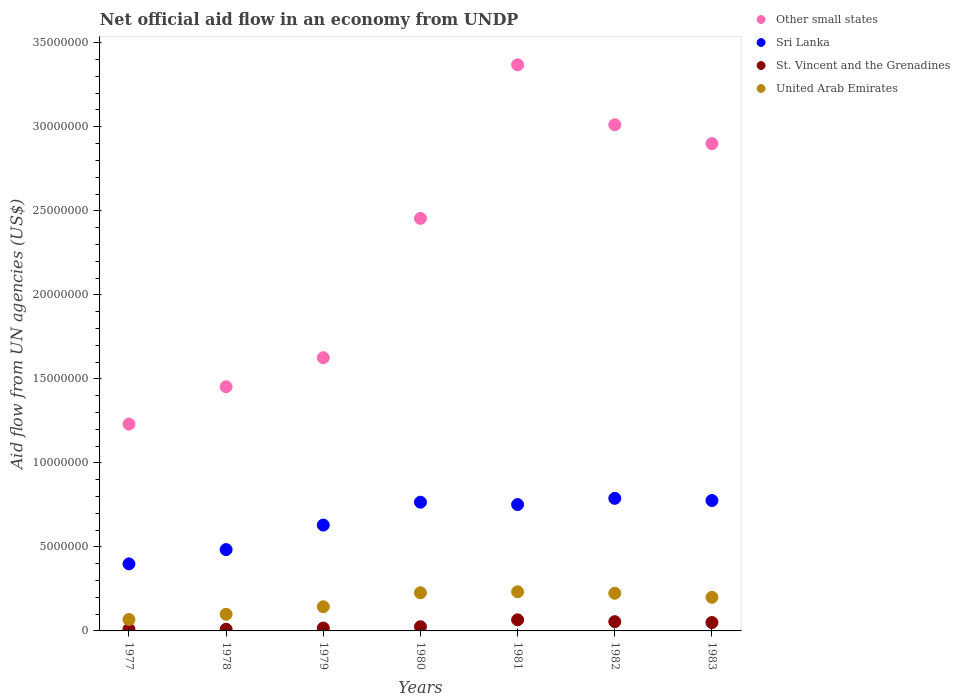What is the net official aid flow in Other small states in 1981?
Give a very brief answer. 3.37e+07. Across all years, what is the maximum net official aid flow in Other small states?
Offer a terse response. 3.37e+07. Across all years, what is the minimum net official aid flow in Other small states?
Provide a short and direct response. 1.23e+07. In which year was the net official aid flow in United Arab Emirates maximum?
Your response must be concise. 1981. What is the total net official aid flow in Other small states in the graph?
Provide a succinct answer. 1.60e+08. What is the difference between the net official aid flow in St. Vincent and the Grenadines in 1978 and that in 1979?
Provide a succinct answer. -7.00e+04. What is the difference between the net official aid flow in St. Vincent and the Grenadines in 1983 and the net official aid flow in United Arab Emirates in 1977?
Your response must be concise. -1.80e+05. What is the average net official aid flow in Sri Lanka per year?
Offer a terse response. 6.57e+06. In the year 1981, what is the difference between the net official aid flow in United Arab Emirates and net official aid flow in Sri Lanka?
Ensure brevity in your answer.  -5.19e+06. In how many years, is the net official aid flow in St. Vincent and the Grenadines greater than 22000000 US$?
Provide a succinct answer. 0. What is the ratio of the net official aid flow in St. Vincent and the Grenadines in 1978 to that in 1982?
Your answer should be very brief. 0.18. Is the difference between the net official aid flow in United Arab Emirates in 1977 and 1983 greater than the difference between the net official aid flow in Sri Lanka in 1977 and 1983?
Your response must be concise. Yes. What is the difference between the highest and the lowest net official aid flow in St. Vincent and the Grenadines?
Make the answer very short. 5.60e+05. In how many years, is the net official aid flow in Sri Lanka greater than the average net official aid flow in Sri Lanka taken over all years?
Your answer should be compact. 4. Is it the case that in every year, the sum of the net official aid flow in St. Vincent and the Grenadines and net official aid flow in Sri Lanka  is greater than the sum of net official aid flow in United Arab Emirates and net official aid flow in Other small states?
Your response must be concise. No. Is the net official aid flow in United Arab Emirates strictly greater than the net official aid flow in Sri Lanka over the years?
Provide a succinct answer. No. What is the difference between two consecutive major ticks on the Y-axis?
Your answer should be compact. 5.00e+06. Does the graph contain any zero values?
Make the answer very short. No. Does the graph contain grids?
Your answer should be compact. No. Where does the legend appear in the graph?
Provide a succinct answer. Top right. How are the legend labels stacked?
Keep it short and to the point. Vertical. What is the title of the graph?
Ensure brevity in your answer.  Net official aid flow in an economy from UNDP. What is the label or title of the Y-axis?
Your answer should be very brief. Aid flow from UN agencies (US$). What is the Aid flow from UN agencies (US$) in Other small states in 1977?
Ensure brevity in your answer.  1.23e+07. What is the Aid flow from UN agencies (US$) in Sri Lanka in 1977?
Provide a short and direct response. 3.99e+06. What is the Aid flow from UN agencies (US$) of United Arab Emirates in 1977?
Provide a succinct answer. 6.80e+05. What is the Aid flow from UN agencies (US$) of Other small states in 1978?
Your answer should be very brief. 1.45e+07. What is the Aid flow from UN agencies (US$) of Sri Lanka in 1978?
Provide a short and direct response. 4.84e+06. What is the Aid flow from UN agencies (US$) in United Arab Emirates in 1978?
Provide a short and direct response. 9.90e+05. What is the Aid flow from UN agencies (US$) in Other small states in 1979?
Your answer should be very brief. 1.63e+07. What is the Aid flow from UN agencies (US$) of Sri Lanka in 1979?
Provide a short and direct response. 6.30e+06. What is the Aid flow from UN agencies (US$) in United Arab Emirates in 1979?
Your answer should be compact. 1.44e+06. What is the Aid flow from UN agencies (US$) in Other small states in 1980?
Offer a terse response. 2.46e+07. What is the Aid flow from UN agencies (US$) in Sri Lanka in 1980?
Your answer should be very brief. 7.66e+06. What is the Aid flow from UN agencies (US$) of United Arab Emirates in 1980?
Provide a succinct answer. 2.27e+06. What is the Aid flow from UN agencies (US$) in Other small states in 1981?
Make the answer very short. 3.37e+07. What is the Aid flow from UN agencies (US$) in Sri Lanka in 1981?
Provide a short and direct response. 7.52e+06. What is the Aid flow from UN agencies (US$) in United Arab Emirates in 1981?
Ensure brevity in your answer.  2.33e+06. What is the Aid flow from UN agencies (US$) in Other small states in 1982?
Give a very brief answer. 3.01e+07. What is the Aid flow from UN agencies (US$) in Sri Lanka in 1982?
Your answer should be very brief. 7.89e+06. What is the Aid flow from UN agencies (US$) in United Arab Emirates in 1982?
Give a very brief answer. 2.24e+06. What is the Aid flow from UN agencies (US$) in Other small states in 1983?
Your answer should be very brief. 2.90e+07. What is the Aid flow from UN agencies (US$) of Sri Lanka in 1983?
Make the answer very short. 7.76e+06. What is the Aid flow from UN agencies (US$) in St. Vincent and the Grenadines in 1983?
Give a very brief answer. 5.00e+05. What is the Aid flow from UN agencies (US$) of United Arab Emirates in 1983?
Provide a succinct answer. 2.00e+06. Across all years, what is the maximum Aid flow from UN agencies (US$) in Other small states?
Make the answer very short. 3.37e+07. Across all years, what is the maximum Aid flow from UN agencies (US$) in Sri Lanka?
Keep it short and to the point. 7.89e+06. Across all years, what is the maximum Aid flow from UN agencies (US$) of St. Vincent and the Grenadines?
Make the answer very short. 6.60e+05. Across all years, what is the maximum Aid flow from UN agencies (US$) in United Arab Emirates?
Ensure brevity in your answer.  2.33e+06. Across all years, what is the minimum Aid flow from UN agencies (US$) in Other small states?
Keep it short and to the point. 1.23e+07. Across all years, what is the minimum Aid flow from UN agencies (US$) of Sri Lanka?
Give a very brief answer. 3.99e+06. Across all years, what is the minimum Aid flow from UN agencies (US$) in United Arab Emirates?
Provide a short and direct response. 6.80e+05. What is the total Aid flow from UN agencies (US$) in Other small states in the graph?
Provide a succinct answer. 1.60e+08. What is the total Aid flow from UN agencies (US$) of Sri Lanka in the graph?
Your response must be concise. 4.60e+07. What is the total Aid flow from UN agencies (US$) in St. Vincent and the Grenadines in the graph?
Give a very brief answer. 2.33e+06. What is the total Aid flow from UN agencies (US$) in United Arab Emirates in the graph?
Your response must be concise. 1.20e+07. What is the difference between the Aid flow from UN agencies (US$) of Other small states in 1977 and that in 1978?
Your answer should be compact. -2.22e+06. What is the difference between the Aid flow from UN agencies (US$) in Sri Lanka in 1977 and that in 1978?
Your answer should be compact. -8.50e+05. What is the difference between the Aid flow from UN agencies (US$) in United Arab Emirates in 1977 and that in 1978?
Keep it short and to the point. -3.10e+05. What is the difference between the Aid flow from UN agencies (US$) of Other small states in 1977 and that in 1979?
Provide a succinct answer. -3.95e+06. What is the difference between the Aid flow from UN agencies (US$) in Sri Lanka in 1977 and that in 1979?
Give a very brief answer. -2.31e+06. What is the difference between the Aid flow from UN agencies (US$) of St. Vincent and the Grenadines in 1977 and that in 1979?
Provide a succinct answer. -7.00e+04. What is the difference between the Aid flow from UN agencies (US$) in United Arab Emirates in 1977 and that in 1979?
Offer a terse response. -7.60e+05. What is the difference between the Aid flow from UN agencies (US$) in Other small states in 1977 and that in 1980?
Keep it short and to the point. -1.22e+07. What is the difference between the Aid flow from UN agencies (US$) in Sri Lanka in 1977 and that in 1980?
Make the answer very short. -3.67e+06. What is the difference between the Aid flow from UN agencies (US$) of St. Vincent and the Grenadines in 1977 and that in 1980?
Your answer should be compact. -1.50e+05. What is the difference between the Aid flow from UN agencies (US$) in United Arab Emirates in 1977 and that in 1980?
Keep it short and to the point. -1.59e+06. What is the difference between the Aid flow from UN agencies (US$) in Other small states in 1977 and that in 1981?
Provide a short and direct response. -2.14e+07. What is the difference between the Aid flow from UN agencies (US$) in Sri Lanka in 1977 and that in 1981?
Offer a very short reply. -3.53e+06. What is the difference between the Aid flow from UN agencies (US$) in St. Vincent and the Grenadines in 1977 and that in 1981?
Make the answer very short. -5.60e+05. What is the difference between the Aid flow from UN agencies (US$) in United Arab Emirates in 1977 and that in 1981?
Provide a short and direct response. -1.65e+06. What is the difference between the Aid flow from UN agencies (US$) of Other small states in 1977 and that in 1982?
Offer a very short reply. -1.78e+07. What is the difference between the Aid flow from UN agencies (US$) in Sri Lanka in 1977 and that in 1982?
Provide a succinct answer. -3.90e+06. What is the difference between the Aid flow from UN agencies (US$) of St. Vincent and the Grenadines in 1977 and that in 1982?
Your answer should be very brief. -4.50e+05. What is the difference between the Aid flow from UN agencies (US$) in United Arab Emirates in 1977 and that in 1982?
Give a very brief answer. -1.56e+06. What is the difference between the Aid flow from UN agencies (US$) in Other small states in 1977 and that in 1983?
Your answer should be compact. -1.67e+07. What is the difference between the Aid flow from UN agencies (US$) of Sri Lanka in 1977 and that in 1983?
Keep it short and to the point. -3.77e+06. What is the difference between the Aid flow from UN agencies (US$) in St. Vincent and the Grenadines in 1977 and that in 1983?
Your answer should be very brief. -4.00e+05. What is the difference between the Aid flow from UN agencies (US$) in United Arab Emirates in 1977 and that in 1983?
Your answer should be compact. -1.32e+06. What is the difference between the Aid flow from UN agencies (US$) in Other small states in 1978 and that in 1979?
Offer a terse response. -1.73e+06. What is the difference between the Aid flow from UN agencies (US$) of Sri Lanka in 1978 and that in 1979?
Offer a very short reply. -1.46e+06. What is the difference between the Aid flow from UN agencies (US$) of St. Vincent and the Grenadines in 1978 and that in 1979?
Provide a short and direct response. -7.00e+04. What is the difference between the Aid flow from UN agencies (US$) of United Arab Emirates in 1978 and that in 1979?
Your answer should be compact. -4.50e+05. What is the difference between the Aid flow from UN agencies (US$) of Other small states in 1978 and that in 1980?
Keep it short and to the point. -1.00e+07. What is the difference between the Aid flow from UN agencies (US$) in Sri Lanka in 1978 and that in 1980?
Ensure brevity in your answer.  -2.82e+06. What is the difference between the Aid flow from UN agencies (US$) of St. Vincent and the Grenadines in 1978 and that in 1980?
Keep it short and to the point. -1.50e+05. What is the difference between the Aid flow from UN agencies (US$) of United Arab Emirates in 1978 and that in 1980?
Provide a succinct answer. -1.28e+06. What is the difference between the Aid flow from UN agencies (US$) of Other small states in 1978 and that in 1981?
Offer a very short reply. -1.92e+07. What is the difference between the Aid flow from UN agencies (US$) of Sri Lanka in 1978 and that in 1981?
Offer a terse response. -2.68e+06. What is the difference between the Aid flow from UN agencies (US$) of St. Vincent and the Grenadines in 1978 and that in 1981?
Keep it short and to the point. -5.60e+05. What is the difference between the Aid flow from UN agencies (US$) in United Arab Emirates in 1978 and that in 1981?
Keep it short and to the point. -1.34e+06. What is the difference between the Aid flow from UN agencies (US$) in Other small states in 1978 and that in 1982?
Your answer should be compact. -1.56e+07. What is the difference between the Aid flow from UN agencies (US$) of Sri Lanka in 1978 and that in 1982?
Ensure brevity in your answer.  -3.05e+06. What is the difference between the Aid flow from UN agencies (US$) of St. Vincent and the Grenadines in 1978 and that in 1982?
Provide a succinct answer. -4.50e+05. What is the difference between the Aid flow from UN agencies (US$) in United Arab Emirates in 1978 and that in 1982?
Your answer should be very brief. -1.25e+06. What is the difference between the Aid flow from UN agencies (US$) in Other small states in 1978 and that in 1983?
Ensure brevity in your answer.  -1.45e+07. What is the difference between the Aid flow from UN agencies (US$) of Sri Lanka in 1978 and that in 1983?
Provide a short and direct response. -2.92e+06. What is the difference between the Aid flow from UN agencies (US$) in St. Vincent and the Grenadines in 1978 and that in 1983?
Provide a short and direct response. -4.00e+05. What is the difference between the Aid flow from UN agencies (US$) in United Arab Emirates in 1978 and that in 1983?
Your answer should be compact. -1.01e+06. What is the difference between the Aid flow from UN agencies (US$) in Other small states in 1979 and that in 1980?
Your answer should be compact. -8.29e+06. What is the difference between the Aid flow from UN agencies (US$) of Sri Lanka in 1979 and that in 1980?
Provide a short and direct response. -1.36e+06. What is the difference between the Aid flow from UN agencies (US$) in United Arab Emirates in 1979 and that in 1980?
Your answer should be very brief. -8.30e+05. What is the difference between the Aid flow from UN agencies (US$) of Other small states in 1979 and that in 1981?
Offer a terse response. -1.74e+07. What is the difference between the Aid flow from UN agencies (US$) in Sri Lanka in 1979 and that in 1981?
Your response must be concise. -1.22e+06. What is the difference between the Aid flow from UN agencies (US$) in St. Vincent and the Grenadines in 1979 and that in 1981?
Your answer should be very brief. -4.90e+05. What is the difference between the Aid flow from UN agencies (US$) of United Arab Emirates in 1979 and that in 1981?
Keep it short and to the point. -8.90e+05. What is the difference between the Aid flow from UN agencies (US$) in Other small states in 1979 and that in 1982?
Provide a short and direct response. -1.39e+07. What is the difference between the Aid flow from UN agencies (US$) of Sri Lanka in 1979 and that in 1982?
Your response must be concise. -1.59e+06. What is the difference between the Aid flow from UN agencies (US$) of St. Vincent and the Grenadines in 1979 and that in 1982?
Make the answer very short. -3.80e+05. What is the difference between the Aid flow from UN agencies (US$) in United Arab Emirates in 1979 and that in 1982?
Give a very brief answer. -8.00e+05. What is the difference between the Aid flow from UN agencies (US$) of Other small states in 1979 and that in 1983?
Ensure brevity in your answer.  -1.27e+07. What is the difference between the Aid flow from UN agencies (US$) of Sri Lanka in 1979 and that in 1983?
Provide a short and direct response. -1.46e+06. What is the difference between the Aid flow from UN agencies (US$) of St. Vincent and the Grenadines in 1979 and that in 1983?
Make the answer very short. -3.30e+05. What is the difference between the Aid flow from UN agencies (US$) of United Arab Emirates in 1979 and that in 1983?
Give a very brief answer. -5.60e+05. What is the difference between the Aid flow from UN agencies (US$) of Other small states in 1980 and that in 1981?
Provide a short and direct response. -9.14e+06. What is the difference between the Aid flow from UN agencies (US$) in Sri Lanka in 1980 and that in 1981?
Provide a succinct answer. 1.40e+05. What is the difference between the Aid flow from UN agencies (US$) of St. Vincent and the Grenadines in 1980 and that in 1981?
Provide a succinct answer. -4.10e+05. What is the difference between the Aid flow from UN agencies (US$) of Other small states in 1980 and that in 1982?
Provide a short and direct response. -5.57e+06. What is the difference between the Aid flow from UN agencies (US$) of St. Vincent and the Grenadines in 1980 and that in 1982?
Your answer should be compact. -3.00e+05. What is the difference between the Aid flow from UN agencies (US$) of Other small states in 1980 and that in 1983?
Your answer should be compact. -4.45e+06. What is the difference between the Aid flow from UN agencies (US$) of St. Vincent and the Grenadines in 1980 and that in 1983?
Provide a short and direct response. -2.50e+05. What is the difference between the Aid flow from UN agencies (US$) in United Arab Emirates in 1980 and that in 1983?
Your response must be concise. 2.70e+05. What is the difference between the Aid flow from UN agencies (US$) in Other small states in 1981 and that in 1982?
Give a very brief answer. 3.57e+06. What is the difference between the Aid flow from UN agencies (US$) in Sri Lanka in 1981 and that in 1982?
Ensure brevity in your answer.  -3.70e+05. What is the difference between the Aid flow from UN agencies (US$) of St. Vincent and the Grenadines in 1981 and that in 1982?
Keep it short and to the point. 1.10e+05. What is the difference between the Aid flow from UN agencies (US$) of Other small states in 1981 and that in 1983?
Give a very brief answer. 4.69e+06. What is the difference between the Aid flow from UN agencies (US$) of St. Vincent and the Grenadines in 1981 and that in 1983?
Ensure brevity in your answer.  1.60e+05. What is the difference between the Aid flow from UN agencies (US$) of Other small states in 1982 and that in 1983?
Your answer should be very brief. 1.12e+06. What is the difference between the Aid flow from UN agencies (US$) in St. Vincent and the Grenadines in 1982 and that in 1983?
Ensure brevity in your answer.  5.00e+04. What is the difference between the Aid flow from UN agencies (US$) in Other small states in 1977 and the Aid flow from UN agencies (US$) in Sri Lanka in 1978?
Offer a terse response. 7.47e+06. What is the difference between the Aid flow from UN agencies (US$) of Other small states in 1977 and the Aid flow from UN agencies (US$) of St. Vincent and the Grenadines in 1978?
Provide a succinct answer. 1.22e+07. What is the difference between the Aid flow from UN agencies (US$) of Other small states in 1977 and the Aid flow from UN agencies (US$) of United Arab Emirates in 1978?
Your answer should be very brief. 1.13e+07. What is the difference between the Aid flow from UN agencies (US$) of Sri Lanka in 1977 and the Aid flow from UN agencies (US$) of St. Vincent and the Grenadines in 1978?
Your answer should be very brief. 3.89e+06. What is the difference between the Aid flow from UN agencies (US$) in Sri Lanka in 1977 and the Aid flow from UN agencies (US$) in United Arab Emirates in 1978?
Provide a short and direct response. 3.00e+06. What is the difference between the Aid flow from UN agencies (US$) of St. Vincent and the Grenadines in 1977 and the Aid flow from UN agencies (US$) of United Arab Emirates in 1978?
Provide a succinct answer. -8.90e+05. What is the difference between the Aid flow from UN agencies (US$) in Other small states in 1977 and the Aid flow from UN agencies (US$) in Sri Lanka in 1979?
Ensure brevity in your answer.  6.01e+06. What is the difference between the Aid flow from UN agencies (US$) in Other small states in 1977 and the Aid flow from UN agencies (US$) in St. Vincent and the Grenadines in 1979?
Your response must be concise. 1.21e+07. What is the difference between the Aid flow from UN agencies (US$) of Other small states in 1977 and the Aid flow from UN agencies (US$) of United Arab Emirates in 1979?
Give a very brief answer. 1.09e+07. What is the difference between the Aid flow from UN agencies (US$) in Sri Lanka in 1977 and the Aid flow from UN agencies (US$) in St. Vincent and the Grenadines in 1979?
Your answer should be compact. 3.82e+06. What is the difference between the Aid flow from UN agencies (US$) in Sri Lanka in 1977 and the Aid flow from UN agencies (US$) in United Arab Emirates in 1979?
Your response must be concise. 2.55e+06. What is the difference between the Aid flow from UN agencies (US$) in St. Vincent and the Grenadines in 1977 and the Aid flow from UN agencies (US$) in United Arab Emirates in 1979?
Provide a succinct answer. -1.34e+06. What is the difference between the Aid flow from UN agencies (US$) of Other small states in 1977 and the Aid flow from UN agencies (US$) of Sri Lanka in 1980?
Offer a terse response. 4.65e+06. What is the difference between the Aid flow from UN agencies (US$) in Other small states in 1977 and the Aid flow from UN agencies (US$) in St. Vincent and the Grenadines in 1980?
Keep it short and to the point. 1.21e+07. What is the difference between the Aid flow from UN agencies (US$) in Other small states in 1977 and the Aid flow from UN agencies (US$) in United Arab Emirates in 1980?
Your answer should be compact. 1.00e+07. What is the difference between the Aid flow from UN agencies (US$) in Sri Lanka in 1977 and the Aid flow from UN agencies (US$) in St. Vincent and the Grenadines in 1980?
Your answer should be compact. 3.74e+06. What is the difference between the Aid flow from UN agencies (US$) of Sri Lanka in 1977 and the Aid flow from UN agencies (US$) of United Arab Emirates in 1980?
Your answer should be compact. 1.72e+06. What is the difference between the Aid flow from UN agencies (US$) of St. Vincent and the Grenadines in 1977 and the Aid flow from UN agencies (US$) of United Arab Emirates in 1980?
Offer a very short reply. -2.17e+06. What is the difference between the Aid flow from UN agencies (US$) of Other small states in 1977 and the Aid flow from UN agencies (US$) of Sri Lanka in 1981?
Your response must be concise. 4.79e+06. What is the difference between the Aid flow from UN agencies (US$) in Other small states in 1977 and the Aid flow from UN agencies (US$) in St. Vincent and the Grenadines in 1981?
Your answer should be compact. 1.16e+07. What is the difference between the Aid flow from UN agencies (US$) of Other small states in 1977 and the Aid flow from UN agencies (US$) of United Arab Emirates in 1981?
Make the answer very short. 9.98e+06. What is the difference between the Aid flow from UN agencies (US$) in Sri Lanka in 1977 and the Aid flow from UN agencies (US$) in St. Vincent and the Grenadines in 1981?
Ensure brevity in your answer.  3.33e+06. What is the difference between the Aid flow from UN agencies (US$) in Sri Lanka in 1977 and the Aid flow from UN agencies (US$) in United Arab Emirates in 1981?
Offer a very short reply. 1.66e+06. What is the difference between the Aid flow from UN agencies (US$) of St. Vincent and the Grenadines in 1977 and the Aid flow from UN agencies (US$) of United Arab Emirates in 1981?
Your answer should be very brief. -2.23e+06. What is the difference between the Aid flow from UN agencies (US$) of Other small states in 1977 and the Aid flow from UN agencies (US$) of Sri Lanka in 1982?
Your answer should be compact. 4.42e+06. What is the difference between the Aid flow from UN agencies (US$) in Other small states in 1977 and the Aid flow from UN agencies (US$) in St. Vincent and the Grenadines in 1982?
Your response must be concise. 1.18e+07. What is the difference between the Aid flow from UN agencies (US$) of Other small states in 1977 and the Aid flow from UN agencies (US$) of United Arab Emirates in 1982?
Your answer should be compact. 1.01e+07. What is the difference between the Aid flow from UN agencies (US$) in Sri Lanka in 1977 and the Aid flow from UN agencies (US$) in St. Vincent and the Grenadines in 1982?
Provide a succinct answer. 3.44e+06. What is the difference between the Aid flow from UN agencies (US$) in Sri Lanka in 1977 and the Aid flow from UN agencies (US$) in United Arab Emirates in 1982?
Keep it short and to the point. 1.75e+06. What is the difference between the Aid flow from UN agencies (US$) of St. Vincent and the Grenadines in 1977 and the Aid flow from UN agencies (US$) of United Arab Emirates in 1982?
Keep it short and to the point. -2.14e+06. What is the difference between the Aid flow from UN agencies (US$) in Other small states in 1977 and the Aid flow from UN agencies (US$) in Sri Lanka in 1983?
Make the answer very short. 4.55e+06. What is the difference between the Aid flow from UN agencies (US$) of Other small states in 1977 and the Aid flow from UN agencies (US$) of St. Vincent and the Grenadines in 1983?
Your response must be concise. 1.18e+07. What is the difference between the Aid flow from UN agencies (US$) of Other small states in 1977 and the Aid flow from UN agencies (US$) of United Arab Emirates in 1983?
Ensure brevity in your answer.  1.03e+07. What is the difference between the Aid flow from UN agencies (US$) of Sri Lanka in 1977 and the Aid flow from UN agencies (US$) of St. Vincent and the Grenadines in 1983?
Your answer should be very brief. 3.49e+06. What is the difference between the Aid flow from UN agencies (US$) of Sri Lanka in 1977 and the Aid flow from UN agencies (US$) of United Arab Emirates in 1983?
Provide a short and direct response. 1.99e+06. What is the difference between the Aid flow from UN agencies (US$) of St. Vincent and the Grenadines in 1977 and the Aid flow from UN agencies (US$) of United Arab Emirates in 1983?
Provide a succinct answer. -1.90e+06. What is the difference between the Aid flow from UN agencies (US$) in Other small states in 1978 and the Aid flow from UN agencies (US$) in Sri Lanka in 1979?
Provide a short and direct response. 8.23e+06. What is the difference between the Aid flow from UN agencies (US$) of Other small states in 1978 and the Aid flow from UN agencies (US$) of St. Vincent and the Grenadines in 1979?
Your answer should be compact. 1.44e+07. What is the difference between the Aid flow from UN agencies (US$) in Other small states in 1978 and the Aid flow from UN agencies (US$) in United Arab Emirates in 1979?
Your response must be concise. 1.31e+07. What is the difference between the Aid flow from UN agencies (US$) of Sri Lanka in 1978 and the Aid flow from UN agencies (US$) of St. Vincent and the Grenadines in 1979?
Offer a very short reply. 4.67e+06. What is the difference between the Aid flow from UN agencies (US$) of Sri Lanka in 1978 and the Aid flow from UN agencies (US$) of United Arab Emirates in 1979?
Keep it short and to the point. 3.40e+06. What is the difference between the Aid flow from UN agencies (US$) of St. Vincent and the Grenadines in 1978 and the Aid flow from UN agencies (US$) of United Arab Emirates in 1979?
Make the answer very short. -1.34e+06. What is the difference between the Aid flow from UN agencies (US$) of Other small states in 1978 and the Aid flow from UN agencies (US$) of Sri Lanka in 1980?
Give a very brief answer. 6.87e+06. What is the difference between the Aid flow from UN agencies (US$) in Other small states in 1978 and the Aid flow from UN agencies (US$) in St. Vincent and the Grenadines in 1980?
Give a very brief answer. 1.43e+07. What is the difference between the Aid flow from UN agencies (US$) in Other small states in 1978 and the Aid flow from UN agencies (US$) in United Arab Emirates in 1980?
Offer a very short reply. 1.23e+07. What is the difference between the Aid flow from UN agencies (US$) of Sri Lanka in 1978 and the Aid flow from UN agencies (US$) of St. Vincent and the Grenadines in 1980?
Your answer should be compact. 4.59e+06. What is the difference between the Aid flow from UN agencies (US$) in Sri Lanka in 1978 and the Aid flow from UN agencies (US$) in United Arab Emirates in 1980?
Your answer should be compact. 2.57e+06. What is the difference between the Aid flow from UN agencies (US$) of St. Vincent and the Grenadines in 1978 and the Aid flow from UN agencies (US$) of United Arab Emirates in 1980?
Your answer should be very brief. -2.17e+06. What is the difference between the Aid flow from UN agencies (US$) of Other small states in 1978 and the Aid flow from UN agencies (US$) of Sri Lanka in 1981?
Your answer should be compact. 7.01e+06. What is the difference between the Aid flow from UN agencies (US$) in Other small states in 1978 and the Aid flow from UN agencies (US$) in St. Vincent and the Grenadines in 1981?
Ensure brevity in your answer.  1.39e+07. What is the difference between the Aid flow from UN agencies (US$) of Other small states in 1978 and the Aid flow from UN agencies (US$) of United Arab Emirates in 1981?
Ensure brevity in your answer.  1.22e+07. What is the difference between the Aid flow from UN agencies (US$) of Sri Lanka in 1978 and the Aid flow from UN agencies (US$) of St. Vincent and the Grenadines in 1981?
Your answer should be very brief. 4.18e+06. What is the difference between the Aid flow from UN agencies (US$) in Sri Lanka in 1978 and the Aid flow from UN agencies (US$) in United Arab Emirates in 1981?
Provide a succinct answer. 2.51e+06. What is the difference between the Aid flow from UN agencies (US$) of St. Vincent and the Grenadines in 1978 and the Aid flow from UN agencies (US$) of United Arab Emirates in 1981?
Keep it short and to the point. -2.23e+06. What is the difference between the Aid flow from UN agencies (US$) in Other small states in 1978 and the Aid flow from UN agencies (US$) in Sri Lanka in 1982?
Give a very brief answer. 6.64e+06. What is the difference between the Aid flow from UN agencies (US$) of Other small states in 1978 and the Aid flow from UN agencies (US$) of St. Vincent and the Grenadines in 1982?
Ensure brevity in your answer.  1.40e+07. What is the difference between the Aid flow from UN agencies (US$) in Other small states in 1978 and the Aid flow from UN agencies (US$) in United Arab Emirates in 1982?
Ensure brevity in your answer.  1.23e+07. What is the difference between the Aid flow from UN agencies (US$) of Sri Lanka in 1978 and the Aid flow from UN agencies (US$) of St. Vincent and the Grenadines in 1982?
Keep it short and to the point. 4.29e+06. What is the difference between the Aid flow from UN agencies (US$) in Sri Lanka in 1978 and the Aid flow from UN agencies (US$) in United Arab Emirates in 1982?
Provide a short and direct response. 2.60e+06. What is the difference between the Aid flow from UN agencies (US$) in St. Vincent and the Grenadines in 1978 and the Aid flow from UN agencies (US$) in United Arab Emirates in 1982?
Keep it short and to the point. -2.14e+06. What is the difference between the Aid flow from UN agencies (US$) in Other small states in 1978 and the Aid flow from UN agencies (US$) in Sri Lanka in 1983?
Provide a short and direct response. 6.77e+06. What is the difference between the Aid flow from UN agencies (US$) of Other small states in 1978 and the Aid flow from UN agencies (US$) of St. Vincent and the Grenadines in 1983?
Ensure brevity in your answer.  1.40e+07. What is the difference between the Aid flow from UN agencies (US$) in Other small states in 1978 and the Aid flow from UN agencies (US$) in United Arab Emirates in 1983?
Your response must be concise. 1.25e+07. What is the difference between the Aid flow from UN agencies (US$) of Sri Lanka in 1978 and the Aid flow from UN agencies (US$) of St. Vincent and the Grenadines in 1983?
Provide a short and direct response. 4.34e+06. What is the difference between the Aid flow from UN agencies (US$) in Sri Lanka in 1978 and the Aid flow from UN agencies (US$) in United Arab Emirates in 1983?
Your answer should be very brief. 2.84e+06. What is the difference between the Aid flow from UN agencies (US$) of St. Vincent and the Grenadines in 1978 and the Aid flow from UN agencies (US$) of United Arab Emirates in 1983?
Provide a short and direct response. -1.90e+06. What is the difference between the Aid flow from UN agencies (US$) of Other small states in 1979 and the Aid flow from UN agencies (US$) of Sri Lanka in 1980?
Provide a succinct answer. 8.60e+06. What is the difference between the Aid flow from UN agencies (US$) of Other small states in 1979 and the Aid flow from UN agencies (US$) of St. Vincent and the Grenadines in 1980?
Provide a succinct answer. 1.60e+07. What is the difference between the Aid flow from UN agencies (US$) of Other small states in 1979 and the Aid flow from UN agencies (US$) of United Arab Emirates in 1980?
Your answer should be very brief. 1.40e+07. What is the difference between the Aid flow from UN agencies (US$) in Sri Lanka in 1979 and the Aid flow from UN agencies (US$) in St. Vincent and the Grenadines in 1980?
Your response must be concise. 6.05e+06. What is the difference between the Aid flow from UN agencies (US$) in Sri Lanka in 1979 and the Aid flow from UN agencies (US$) in United Arab Emirates in 1980?
Give a very brief answer. 4.03e+06. What is the difference between the Aid flow from UN agencies (US$) of St. Vincent and the Grenadines in 1979 and the Aid flow from UN agencies (US$) of United Arab Emirates in 1980?
Provide a short and direct response. -2.10e+06. What is the difference between the Aid flow from UN agencies (US$) of Other small states in 1979 and the Aid flow from UN agencies (US$) of Sri Lanka in 1981?
Make the answer very short. 8.74e+06. What is the difference between the Aid flow from UN agencies (US$) in Other small states in 1979 and the Aid flow from UN agencies (US$) in St. Vincent and the Grenadines in 1981?
Offer a terse response. 1.56e+07. What is the difference between the Aid flow from UN agencies (US$) of Other small states in 1979 and the Aid flow from UN agencies (US$) of United Arab Emirates in 1981?
Ensure brevity in your answer.  1.39e+07. What is the difference between the Aid flow from UN agencies (US$) of Sri Lanka in 1979 and the Aid flow from UN agencies (US$) of St. Vincent and the Grenadines in 1981?
Offer a terse response. 5.64e+06. What is the difference between the Aid flow from UN agencies (US$) of Sri Lanka in 1979 and the Aid flow from UN agencies (US$) of United Arab Emirates in 1981?
Offer a very short reply. 3.97e+06. What is the difference between the Aid flow from UN agencies (US$) in St. Vincent and the Grenadines in 1979 and the Aid flow from UN agencies (US$) in United Arab Emirates in 1981?
Offer a very short reply. -2.16e+06. What is the difference between the Aid flow from UN agencies (US$) of Other small states in 1979 and the Aid flow from UN agencies (US$) of Sri Lanka in 1982?
Offer a terse response. 8.37e+06. What is the difference between the Aid flow from UN agencies (US$) of Other small states in 1979 and the Aid flow from UN agencies (US$) of St. Vincent and the Grenadines in 1982?
Keep it short and to the point. 1.57e+07. What is the difference between the Aid flow from UN agencies (US$) of Other small states in 1979 and the Aid flow from UN agencies (US$) of United Arab Emirates in 1982?
Your answer should be very brief. 1.40e+07. What is the difference between the Aid flow from UN agencies (US$) of Sri Lanka in 1979 and the Aid flow from UN agencies (US$) of St. Vincent and the Grenadines in 1982?
Your answer should be compact. 5.75e+06. What is the difference between the Aid flow from UN agencies (US$) in Sri Lanka in 1979 and the Aid flow from UN agencies (US$) in United Arab Emirates in 1982?
Keep it short and to the point. 4.06e+06. What is the difference between the Aid flow from UN agencies (US$) in St. Vincent and the Grenadines in 1979 and the Aid flow from UN agencies (US$) in United Arab Emirates in 1982?
Your answer should be compact. -2.07e+06. What is the difference between the Aid flow from UN agencies (US$) of Other small states in 1979 and the Aid flow from UN agencies (US$) of Sri Lanka in 1983?
Offer a very short reply. 8.50e+06. What is the difference between the Aid flow from UN agencies (US$) in Other small states in 1979 and the Aid flow from UN agencies (US$) in St. Vincent and the Grenadines in 1983?
Your response must be concise. 1.58e+07. What is the difference between the Aid flow from UN agencies (US$) of Other small states in 1979 and the Aid flow from UN agencies (US$) of United Arab Emirates in 1983?
Keep it short and to the point. 1.43e+07. What is the difference between the Aid flow from UN agencies (US$) in Sri Lanka in 1979 and the Aid flow from UN agencies (US$) in St. Vincent and the Grenadines in 1983?
Provide a short and direct response. 5.80e+06. What is the difference between the Aid flow from UN agencies (US$) in Sri Lanka in 1979 and the Aid flow from UN agencies (US$) in United Arab Emirates in 1983?
Offer a very short reply. 4.30e+06. What is the difference between the Aid flow from UN agencies (US$) of St. Vincent and the Grenadines in 1979 and the Aid flow from UN agencies (US$) of United Arab Emirates in 1983?
Make the answer very short. -1.83e+06. What is the difference between the Aid flow from UN agencies (US$) of Other small states in 1980 and the Aid flow from UN agencies (US$) of Sri Lanka in 1981?
Make the answer very short. 1.70e+07. What is the difference between the Aid flow from UN agencies (US$) of Other small states in 1980 and the Aid flow from UN agencies (US$) of St. Vincent and the Grenadines in 1981?
Offer a terse response. 2.39e+07. What is the difference between the Aid flow from UN agencies (US$) of Other small states in 1980 and the Aid flow from UN agencies (US$) of United Arab Emirates in 1981?
Your answer should be compact. 2.22e+07. What is the difference between the Aid flow from UN agencies (US$) of Sri Lanka in 1980 and the Aid flow from UN agencies (US$) of St. Vincent and the Grenadines in 1981?
Offer a terse response. 7.00e+06. What is the difference between the Aid flow from UN agencies (US$) of Sri Lanka in 1980 and the Aid flow from UN agencies (US$) of United Arab Emirates in 1981?
Provide a succinct answer. 5.33e+06. What is the difference between the Aid flow from UN agencies (US$) of St. Vincent and the Grenadines in 1980 and the Aid flow from UN agencies (US$) of United Arab Emirates in 1981?
Provide a short and direct response. -2.08e+06. What is the difference between the Aid flow from UN agencies (US$) of Other small states in 1980 and the Aid flow from UN agencies (US$) of Sri Lanka in 1982?
Provide a succinct answer. 1.67e+07. What is the difference between the Aid flow from UN agencies (US$) in Other small states in 1980 and the Aid flow from UN agencies (US$) in St. Vincent and the Grenadines in 1982?
Keep it short and to the point. 2.40e+07. What is the difference between the Aid flow from UN agencies (US$) of Other small states in 1980 and the Aid flow from UN agencies (US$) of United Arab Emirates in 1982?
Offer a terse response. 2.23e+07. What is the difference between the Aid flow from UN agencies (US$) of Sri Lanka in 1980 and the Aid flow from UN agencies (US$) of St. Vincent and the Grenadines in 1982?
Offer a very short reply. 7.11e+06. What is the difference between the Aid flow from UN agencies (US$) of Sri Lanka in 1980 and the Aid flow from UN agencies (US$) of United Arab Emirates in 1982?
Your answer should be very brief. 5.42e+06. What is the difference between the Aid flow from UN agencies (US$) in St. Vincent and the Grenadines in 1980 and the Aid flow from UN agencies (US$) in United Arab Emirates in 1982?
Provide a succinct answer. -1.99e+06. What is the difference between the Aid flow from UN agencies (US$) of Other small states in 1980 and the Aid flow from UN agencies (US$) of Sri Lanka in 1983?
Your response must be concise. 1.68e+07. What is the difference between the Aid flow from UN agencies (US$) in Other small states in 1980 and the Aid flow from UN agencies (US$) in St. Vincent and the Grenadines in 1983?
Ensure brevity in your answer.  2.40e+07. What is the difference between the Aid flow from UN agencies (US$) of Other small states in 1980 and the Aid flow from UN agencies (US$) of United Arab Emirates in 1983?
Your answer should be compact. 2.26e+07. What is the difference between the Aid flow from UN agencies (US$) in Sri Lanka in 1980 and the Aid flow from UN agencies (US$) in St. Vincent and the Grenadines in 1983?
Make the answer very short. 7.16e+06. What is the difference between the Aid flow from UN agencies (US$) in Sri Lanka in 1980 and the Aid flow from UN agencies (US$) in United Arab Emirates in 1983?
Your response must be concise. 5.66e+06. What is the difference between the Aid flow from UN agencies (US$) in St. Vincent and the Grenadines in 1980 and the Aid flow from UN agencies (US$) in United Arab Emirates in 1983?
Your answer should be compact. -1.75e+06. What is the difference between the Aid flow from UN agencies (US$) of Other small states in 1981 and the Aid flow from UN agencies (US$) of Sri Lanka in 1982?
Offer a very short reply. 2.58e+07. What is the difference between the Aid flow from UN agencies (US$) in Other small states in 1981 and the Aid flow from UN agencies (US$) in St. Vincent and the Grenadines in 1982?
Keep it short and to the point. 3.31e+07. What is the difference between the Aid flow from UN agencies (US$) of Other small states in 1981 and the Aid flow from UN agencies (US$) of United Arab Emirates in 1982?
Give a very brief answer. 3.14e+07. What is the difference between the Aid flow from UN agencies (US$) of Sri Lanka in 1981 and the Aid flow from UN agencies (US$) of St. Vincent and the Grenadines in 1982?
Offer a terse response. 6.97e+06. What is the difference between the Aid flow from UN agencies (US$) of Sri Lanka in 1981 and the Aid flow from UN agencies (US$) of United Arab Emirates in 1982?
Provide a succinct answer. 5.28e+06. What is the difference between the Aid flow from UN agencies (US$) of St. Vincent and the Grenadines in 1981 and the Aid flow from UN agencies (US$) of United Arab Emirates in 1982?
Provide a short and direct response. -1.58e+06. What is the difference between the Aid flow from UN agencies (US$) in Other small states in 1981 and the Aid flow from UN agencies (US$) in Sri Lanka in 1983?
Provide a short and direct response. 2.59e+07. What is the difference between the Aid flow from UN agencies (US$) in Other small states in 1981 and the Aid flow from UN agencies (US$) in St. Vincent and the Grenadines in 1983?
Keep it short and to the point. 3.32e+07. What is the difference between the Aid flow from UN agencies (US$) in Other small states in 1981 and the Aid flow from UN agencies (US$) in United Arab Emirates in 1983?
Keep it short and to the point. 3.17e+07. What is the difference between the Aid flow from UN agencies (US$) in Sri Lanka in 1981 and the Aid flow from UN agencies (US$) in St. Vincent and the Grenadines in 1983?
Give a very brief answer. 7.02e+06. What is the difference between the Aid flow from UN agencies (US$) of Sri Lanka in 1981 and the Aid flow from UN agencies (US$) of United Arab Emirates in 1983?
Your answer should be compact. 5.52e+06. What is the difference between the Aid flow from UN agencies (US$) of St. Vincent and the Grenadines in 1981 and the Aid flow from UN agencies (US$) of United Arab Emirates in 1983?
Ensure brevity in your answer.  -1.34e+06. What is the difference between the Aid flow from UN agencies (US$) of Other small states in 1982 and the Aid flow from UN agencies (US$) of Sri Lanka in 1983?
Provide a short and direct response. 2.24e+07. What is the difference between the Aid flow from UN agencies (US$) of Other small states in 1982 and the Aid flow from UN agencies (US$) of St. Vincent and the Grenadines in 1983?
Offer a terse response. 2.96e+07. What is the difference between the Aid flow from UN agencies (US$) in Other small states in 1982 and the Aid flow from UN agencies (US$) in United Arab Emirates in 1983?
Offer a very short reply. 2.81e+07. What is the difference between the Aid flow from UN agencies (US$) in Sri Lanka in 1982 and the Aid flow from UN agencies (US$) in St. Vincent and the Grenadines in 1983?
Provide a short and direct response. 7.39e+06. What is the difference between the Aid flow from UN agencies (US$) in Sri Lanka in 1982 and the Aid flow from UN agencies (US$) in United Arab Emirates in 1983?
Your answer should be very brief. 5.89e+06. What is the difference between the Aid flow from UN agencies (US$) of St. Vincent and the Grenadines in 1982 and the Aid flow from UN agencies (US$) of United Arab Emirates in 1983?
Provide a short and direct response. -1.45e+06. What is the average Aid flow from UN agencies (US$) in Other small states per year?
Your response must be concise. 2.29e+07. What is the average Aid flow from UN agencies (US$) in Sri Lanka per year?
Make the answer very short. 6.57e+06. What is the average Aid flow from UN agencies (US$) in St. Vincent and the Grenadines per year?
Give a very brief answer. 3.33e+05. What is the average Aid flow from UN agencies (US$) of United Arab Emirates per year?
Give a very brief answer. 1.71e+06. In the year 1977, what is the difference between the Aid flow from UN agencies (US$) in Other small states and Aid flow from UN agencies (US$) in Sri Lanka?
Your response must be concise. 8.32e+06. In the year 1977, what is the difference between the Aid flow from UN agencies (US$) in Other small states and Aid flow from UN agencies (US$) in St. Vincent and the Grenadines?
Give a very brief answer. 1.22e+07. In the year 1977, what is the difference between the Aid flow from UN agencies (US$) of Other small states and Aid flow from UN agencies (US$) of United Arab Emirates?
Provide a short and direct response. 1.16e+07. In the year 1977, what is the difference between the Aid flow from UN agencies (US$) in Sri Lanka and Aid flow from UN agencies (US$) in St. Vincent and the Grenadines?
Your answer should be compact. 3.89e+06. In the year 1977, what is the difference between the Aid flow from UN agencies (US$) of Sri Lanka and Aid flow from UN agencies (US$) of United Arab Emirates?
Keep it short and to the point. 3.31e+06. In the year 1977, what is the difference between the Aid flow from UN agencies (US$) in St. Vincent and the Grenadines and Aid flow from UN agencies (US$) in United Arab Emirates?
Make the answer very short. -5.80e+05. In the year 1978, what is the difference between the Aid flow from UN agencies (US$) in Other small states and Aid flow from UN agencies (US$) in Sri Lanka?
Give a very brief answer. 9.69e+06. In the year 1978, what is the difference between the Aid flow from UN agencies (US$) of Other small states and Aid flow from UN agencies (US$) of St. Vincent and the Grenadines?
Give a very brief answer. 1.44e+07. In the year 1978, what is the difference between the Aid flow from UN agencies (US$) of Other small states and Aid flow from UN agencies (US$) of United Arab Emirates?
Your response must be concise. 1.35e+07. In the year 1978, what is the difference between the Aid flow from UN agencies (US$) of Sri Lanka and Aid flow from UN agencies (US$) of St. Vincent and the Grenadines?
Offer a terse response. 4.74e+06. In the year 1978, what is the difference between the Aid flow from UN agencies (US$) of Sri Lanka and Aid flow from UN agencies (US$) of United Arab Emirates?
Provide a succinct answer. 3.85e+06. In the year 1978, what is the difference between the Aid flow from UN agencies (US$) of St. Vincent and the Grenadines and Aid flow from UN agencies (US$) of United Arab Emirates?
Make the answer very short. -8.90e+05. In the year 1979, what is the difference between the Aid flow from UN agencies (US$) of Other small states and Aid flow from UN agencies (US$) of Sri Lanka?
Provide a short and direct response. 9.96e+06. In the year 1979, what is the difference between the Aid flow from UN agencies (US$) in Other small states and Aid flow from UN agencies (US$) in St. Vincent and the Grenadines?
Your response must be concise. 1.61e+07. In the year 1979, what is the difference between the Aid flow from UN agencies (US$) in Other small states and Aid flow from UN agencies (US$) in United Arab Emirates?
Your answer should be very brief. 1.48e+07. In the year 1979, what is the difference between the Aid flow from UN agencies (US$) of Sri Lanka and Aid flow from UN agencies (US$) of St. Vincent and the Grenadines?
Offer a very short reply. 6.13e+06. In the year 1979, what is the difference between the Aid flow from UN agencies (US$) of Sri Lanka and Aid flow from UN agencies (US$) of United Arab Emirates?
Provide a short and direct response. 4.86e+06. In the year 1979, what is the difference between the Aid flow from UN agencies (US$) in St. Vincent and the Grenadines and Aid flow from UN agencies (US$) in United Arab Emirates?
Keep it short and to the point. -1.27e+06. In the year 1980, what is the difference between the Aid flow from UN agencies (US$) of Other small states and Aid flow from UN agencies (US$) of Sri Lanka?
Your answer should be very brief. 1.69e+07. In the year 1980, what is the difference between the Aid flow from UN agencies (US$) in Other small states and Aid flow from UN agencies (US$) in St. Vincent and the Grenadines?
Ensure brevity in your answer.  2.43e+07. In the year 1980, what is the difference between the Aid flow from UN agencies (US$) in Other small states and Aid flow from UN agencies (US$) in United Arab Emirates?
Provide a succinct answer. 2.23e+07. In the year 1980, what is the difference between the Aid flow from UN agencies (US$) in Sri Lanka and Aid flow from UN agencies (US$) in St. Vincent and the Grenadines?
Make the answer very short. 7.41e+06. In the year 1980, what is the difference between the Aid flow from UN agencies (US$) of Sri Lanka and Aid flow from UN agencies (US$) of United Arab Emirates?
Your answer should be very brief. 5.39e+06. In the year 1980, what is the difference between the Aid flow from UN agencies (US$) in St. Vincent and the Grenadines and Aid flow from UN agencies (US$) in United Arab Emirates?
Keep it short and to the point. -2.02e+06. In the year 1981, what is the difference between the Aid flow from UN agencies (US$) of Other small states and Aid flow from UN agencies (US$) of Sri Lanka?
Ensure brevity in your answer.  2.62e+07. In the year 1981, what is the difference between the Aid flow from UN agencies (US$) of Other small states and Aid flow from UN agencies (US$) of St. Vincent and the Grenadines?
Offer a very short reply. 3.30e+07. In the year 1981, what is the difference between the Aid flow from UN agencies (US$) of Other small states and Aid flow from UN agencies (US$) of United Arab Emirates?
Your answer should be very brief. 3.14e+07. In the year 1981, what is the difference between the Aid flow from UN agencies (US$) in Sri Lanka and Aid flow from UN agencies (US$) in St. Vincent and the Grenadines?
Provide a succinct answer. 6.86e+06. In the year 1981, what is the difference between the Aid flow from UN agencies (US$) in Sri Lanka and Aid flow from UN agencies (US$) in United Arab Emirates?
Ensure brevity in your answer.  5.19e+06. In the year 1981, what is the difference between the Aid flow from UN agencies (US$) in St. Vincent and the Grenadines and Aid flow from UN agencies (US$) in United Arab Emirates?
Ensure brevity in your answer.  -1.67e+06. In the year 1982, what is the difference between the Aid flow from UN agencies (US$) in Other small states and Aid flow from UN agencies (US$) in Sri Lanka?
Your answer should be compact. 2.22e+07. In the year 1982, what is the difference between the Aid flow from UN agencies (US$) of Other small states and Aid flow from UN agencies (US$) of St. Vincent and the Grenadines?
Ensure brevity in your answer.  2.96e+07. In the year 1982, what is the difference between the Aid flow from UN agencies (US$) in Other small states and Aid flow from UN agencies (US$) in United Arab Emirates?
Ensure brevity in your answer.  2.79e+07. In the year 1982, what is the difference between the Aid flow from UN agencies (US$) in Sri Lanka and Aid flow from UN agencies (US$) in St. Vincent and the Grenadines?
Provide a succinct answer. 7.34e+06. In the year 1982, what is the difference between the Aid flow from UN agencies (US$) in Sri Lanka and Aid flow from UN agencies (US$) in United Arab Emirates?
Keep it short and to the point. 5.65e+06. In the year 1982, what is the difference between the Aid flow from UN agencies (US$) in St. Vincent and the Grenadines and Aid flow from UN agencies (US$) in United Arab Emirates?
Offer a terse response. -1.69e+06. In the year 1983, what is the difference between the Aid flow from UN agencies (US$) in Other small states and Aid flow from UN agencies (US$) in Sri Lanka?
Ensure brevity in your answer.  2.12e+07. In the year 1983, what is the difference between the Aid flow from UN agencies (US$) in Other small states and Aid flow from UN agencies (US$) in St. Vincent and the Grenadines?
Give a very brief answer. 2.85e+07. In the year 1983, what is the difference between the Aid flow from UN agencies (US$) of Other small states and Aid flow from UN agencies (US$) of United Arab Emirates?
Provide a short and direct response. 2.70e+07. In the year 1983, what is the difference between the Aid flow from UN agencies (US$) of Sri Lanka and Aid flow from UN agencies (US$) of St. Vincent and the Grenadines?
Give a very brief answer. 7.26e+06. In the year 1983, what is the difference between the Aid flow from UN agencies (US$) of Sri Lanka and Aid flow from UN agencies (US$) of United Arab Emirates?
Offer a terse response. 5.76e+06. In the year 1983, what is the difference between the Aid flow from UN agencies (US$) in St. Vincent and the Grenadines and Aid flow from UN agencies (US$) in United Arab Emirates?
Make the answer very short. -1.50e+06. What is the ratio of the Aid flow from UN agencies (US$) in Other small states in 1977 to that in 1978?
Your answer should be very brief. 0.85. What is the ratio of the Aid flow from UN agencies (US$) in Sri Lanka in 1977 to that in 1978?
Give a very brief answer. 0.82. What is the ratio of the Aid flow from UN agencies (US$) of St. Vincent and the Grenadines in 1977 to that in 1978?
Your answer should be very brief. 1. What is the ratio of the Aid flow from UN agencies (US$) in United Arab Emirates in 1977 to that in 1978?
Provide a succinct answer. 0.69. What is the ratio of the Aid flow from UN agencies (US$) in Other small states in 1977 to that in 1979?
Your answer should be compact. 0.76. What is the ratio of the Aid flow from UN agencies (US$) of Sri Lanka in 1977 to that in 1979?
Your response must be concise. 0.63. What is the ratio of the Aid flow from UN agencies (US$) of St. Vincent and the Grenadines in 1977 to that in 1979?
Give a very brief answer. 0.59. What is the ratio of the Aid flow from UN agencies (US$) of United Arab Emirates in 1977 to that in 1979?
Make the answer very short. 0.47. What is the ratio of the Aid flow from UN agencies (US$) of Other small states in 1977 to that in 1980?
Offer a very short reply. 0.5. What is the ratio of the Aid flow from UN agencies (US$) of Sri Lanka in 1977 to that in 1980?
Offer a very short reply. 0.52. What is the ratio of the Aid flow from UN agencies (US$) of St. Vincent and the Grenadines in 1977 to that in 1980?
Offer a very short reply. 0.4. What is the ratio of the Aid flow from UN agencies (US$) of United Arab Emirates in 1977 to that in 1980?
Provide a short and direct response. 0.3. What is the ratio of the Aid flow from UN agencies (US$) in Other small states in 1977 to that in 1981?
Ensure brevity in your answer.  0.37. What is the ratio of the Aid flow from UN agencies (US$) of Sri Lanka in 1977 to that in 1981?
Your response must be concise. 0.53. What is the ratio of the Aid flow from UN agencies (US$) of St. Vincent and the Grenadines in 1977 to that in 1981?
Your response must be concise. 0.15. What is the ratio of the Aid flow from UN agencies (US$) in United Arab Emirates in 1977 to that in 1981?
Ensure brevity in your answer.  0.29. What is the ratio of the Aid flow from UN agencies (US$) in Other small states in 1977 to that in 1982?
Your answer should be compact. 0.41. What is the ratio of the Aid flow from UN agencies (US$) in Sri Lanka in 1977 to that in 1982?
Ensure brevity in your answer.  0.51. What is the ratio of the Aid flow from UN agencies (US$) of St. Vincent and the Grenadines in 1977 to that in 1982?
Provide a short and direct response. 0.18. What is the ratio of the Aid flow from UN agencies (US$) of United Arab Emirates in 1977 to that in 1982?
Your answer should be compact. 0.3. What is the ratio of the Aid flow from UN agencies (US$) in Other small states in 1977 to that in 1983?
Your response must be concise. 0.42. What is the ratio of the Aid flow from UN agencies (US$) in Sri Lanka in 1977 to that in 1983?
Ensure brevity in your answer.  0.51. What is the ratio of the Aid flow from UN agencies (US$) in St. Vincent and the Grenadines in 1977 to that in 1983?
Offer a very short reply. 0.2. What is the ratio of the Aid flow from UN agencies (US$) of United Arab Emirates in 1977 to that in 1983?
Provide a succinct answer. 0.34. What is the ratio of the Aid flow from UN agencies (US$) in Other small states in 1978 to that in 1979?
Give a very brief answer. 0.89. What is the ratio of the Aid flow from UN agencies (US$) of Sri Lanka in 1978 to that in 1979?
Your answer should be compact. 0.77. What is the ratio of the Aid flow from UN agencies (US$) in St. Vincent and the Grenadines in 1978 to that in 1979?
Make the answer very short. 0.59. What is the ratio of the Aid flow from UN agencies (US$) of United Arab Emirates in 1978 to that in 1979?
Your response must be concise. 0.69. What is the ratio of the Aid flow from UN agencies (US$) in Other small states in 1978 to that in 1980?
Offer a very short reply. 0.59. What is the ratio of the Aid flow from UN agencies (US$) in Sri Lanka in 1978 to that in 1980?
Your response must be concise. 0.63. What is the ratio of the Aid flow from UN agencies (US$) of United Arab Emirates in 1978 to that in 1980?
Make the answer very short. 0.44. What is the ratio of the Aid flow from UN agencies (US$) in Other small states in 1978 to that in 1981?
Keep it short and to the point. 0.43. What is the ratio of the Aid flow from UN agencies (US$) of Sri Lanka in 1978 to that in 1981?
Ensure brevity in your answer.  0.64. What is the ratio of the Aid flow from UN agencies (US$) in St. Vincent and the Grenadines in 1978 to that in 1981?
Provide a succinct answer. 0.15. What is the ratio of the Aid flow from UN agencies (US$) in United Arab Emirates in 1978 to that in 1981?
Offer a terse response. 0.42. What is the ratio of the Aid flow from UN agencies (US$) in Other small states in 1978 to that in 1982?
Offer a very short reply. 0.48. What is the ratio of the Aid flow from UN agencies (US$) of Sri Lanka in 1978 to that in 1982?
Your response must be concise. 0.61. What is the ratio of the Aid flow from UN agencies (US$) of St. Vincent and the Grenadines in 1978 to that in 1982?
Provide a succinct answer. 0.18. What is the ratio of the Aid flow from UN agencies (US$) in United Arab Emirates in 1978 to that in 1982?
Keep it short and to the point. 0.44. What is the ratio of the Aid flow from UN agencies (US$) in Other small states in 1978 to that in 1983?
Keep it short and to the point. 0.5. What is the ratio of the Aid flow from UN agencies (US$) of Sri Lanka in 1978 to that in 1983?
Provide a succinct answer. 0.62. What is the ratio of the Aid flow from UN agencies (US$) of United Arab Emirates in 1978 to that in 1983?
Your answer should be compact. 0.49. What is the ratio of the Aid flow from UN agencies (US$) in Other small states in 1979 to that in 1980?
Keep it short and to the point. 0.66. What is the ratio of the Aid flow from UN agencies (US$) of Sri Lanka in 1979 to that in 1980?
Give a very brief answer. 0.82. What is the ratio of the Aid flow from UN agencies (US$) in St. Vincent and the Grenadines in 1979 to that in 1980?
Make the answer very short. 0.68. What is the ratio of the Aid flow from UN agencies (US$) of United Arab Emirates in 1979 to that in 1980?
Give a very brief answer. 0.63. What is the ratio of the Aid flow from UN agencies (US$) of Other small states in 1979 to that in 1981?
Provide a succinct answer. 0.48. What is the ratio of the Aid flow from UN agencies (US$) of Sri Lanka in 1979 to that in 1981?
Make the answer very short. 0.84. What is the ratio of the Aid flow from UN agencies (US$) in St. Vincent and the Grenadines in 1979 to that in 1981?
Give a very brief answer. 0.26. What is the ratio of the Aid flow from UN agencies (US$) of United Arab Emirates in 1979 to that in 1981?
Make the answer very short. 0.62. What is the ratio of the Aid flow from UN agencies (US$) in Other small states in 1979 to that in 1982?
Keep it short and to the point. 0.54. What is the ratio of the Aid flow from UN agencies (US$) in Sri Lanka in 1979 to that in 1982?
Offer a terse response. 0.8. What is the ratio of the Aid flow from UN agencies (US$) in St. Vincent and the Grenadines in 1979 to that in 1982?
Make the answer very short. 0.31. What is the ratio of the Aid flow from UN agencies (US$) in United Arab Emirates in 1979 to that in 1982?
Offer a very short reply. 0.64. What is the ratio of the Aid flow from UN agencies (US$) of Other small states in 1979 to that in 1983?
Provide a succinct answer. 0.56. What is the ratio of the Aid flow from UN agencies (US$) of Sri Lanka in 1979 to that in 1983?
Give a very brief answer. 0.81. What is the ratio of the Aid flow from UN agencies (US$) in St. Vincent and the Grenadines in 1979 to that in 1983?
Provide a short and direct response. 0.34. What is the ratio of the Aid flow from UN agencies (US$) of United Arab Emirates in 1979 to that in 1983?
Give a very brief answer. 0.72. What is the ratio of the Aid flow from UN agencies (US$) of Other small states in 1980 to that in 1981?
Your response must be concise. 0.73. What is the ratio of the Aid flow from UN agencies (US$) in Sri Lanka in 1980 to that in 1981?
Provide a succinct answer. 1.02. What is the ratio of the Aid flow from UN agencies (US$) of St. Vincent and the Grenadines in 1980 to that in 1981?
Your answer should be very brief. 0.38. What is the ratio of the Aid flow from UN agencies (US$) in United Arab Emirates in 1980 to that in 1981?
Your answer should be compact. 0.97. What is the ratio of the Aid flow from UN agencies (US$) in Other small states in 1980 to that in 1982?
Your response must be concise. 0.82. What is the ratio of the Aid flow from UN agencies (US$) in Sri Lanka in 1980 to that in 1982?
Your answer should be compact. 0.97. What is the ratio of the Aid flow from UN agencies (US$) of St. Vincent and the Grenadines in 1980 to that in 1982?
Your answer should be very brief. 0.45. What is the ratio of the Aid flow from UN agencies (US$) of United Arab Emirates in 1980 to that in 1982?
Your response must be concise. 1.01. What is the ratio of the Aid flow from UN agencies (US$) of Other small states in 1980 to that in 1983?
Your answer should be compact. 0.85. What is the ratio of the Aid flow from UN agencies (US$) in Sri Lanka in 1980 to that in 1983?
Offer a terse response. 0.99. What is the ratio of the Aid flow from UN agencies (US$) of United Arab Emirates in 1980 to that in 1983?
Provide a short and direct response. 1.14. What is the ratio of the Aid flow from UN agencies (US$) of Other small states in 1981 to that in 1982?
Offer a very short reply. 1.12. What is the ratio of the Aid flow from UN agencies (US$) of Sri Lanka in 1981 to that in 1982?
Your response must be concise. 0.95. What is the ratio of the Aid flow from UN agencies (US$) of St. Vincent and the Grenadines in 1981 to that in 1982?
Offer a terse response. 1.2. What is the ratio of the Aid flow from UN agencies (US$) in United Arab Emirates in 1981 to that in 1982?
Keep it short and to the point. 1.04. What is the ratio of the Aid flow from UN agencies (US$) of Other small states in 1981 to that in 1983?
Ensure brevity in your answer.  1.16. What is the ratio of the Aid flow from UN agencies (US$) in Sri Lanka in 1981 to that in 1983?
Make the answer very short. 0.97. What is the ratio of the Aid flow from UN agencies (US$) in St. Vincent and the Grenadines in 1981 to that in 1983?
Ensure brevity in your answer.  1.32. What is the ratio of the Aid flow from UN agencies (US$) of United Arab Emirates in 1981 to that in 1983?
Keep it short and to the point. 1.17. What is the ratio of the Aid flow from UN agencies (US$) of Other small states in 1982 to that in 1983?
Offer a very short reply. 1.04. What is the ratio of the Aid flow from UN agencies (US$) of Sri Lanka in 1982 to that in 1983?
Ensure brevity in your answer.  1.02. What is the ratio of the Aid flow from UN agencies (US$) in St. Vincent and the Grenadines in 1982 to that in 1983?
Your answer should be very brief. 1.1. What is the ratio of the Aid flow from UN agencies (US$) of United Arab Emirates in 1982 to that in 1983?
Ensure brevity in your answer.  1.12. What is the difference between the highest and the second highest Aid flow from UN agencies (US$) of Other small states?
Provide a short and direct response. 3.57e+06. What is the difference between the highest and the second highest Aid flow from UN agencies (US$) in Sri Lanka?
Keep it short and to the point. 1.30e+05. What is the difference between the highest and the lowest Aid flow from UN agencies (US$) of Other small states?
Keep it short and to the point. 2.14e+07. What is the difference between the highest and the lowest Aid flow from UN agencies (US$) of Sri Lanka?
Ensure brevity in your answer.  3.90e+06. What is the difference between the highest and the lowest Aid flow from UN agencies (US$) of St. Vincent and the Grenadines?
Provide a succinct answer. 5.60e+05. What is the difference between the highest and the lowest Aid flow from UN agencies (US$) of United Arab Emirates?
Your response must be concise. 1.65e+06. 